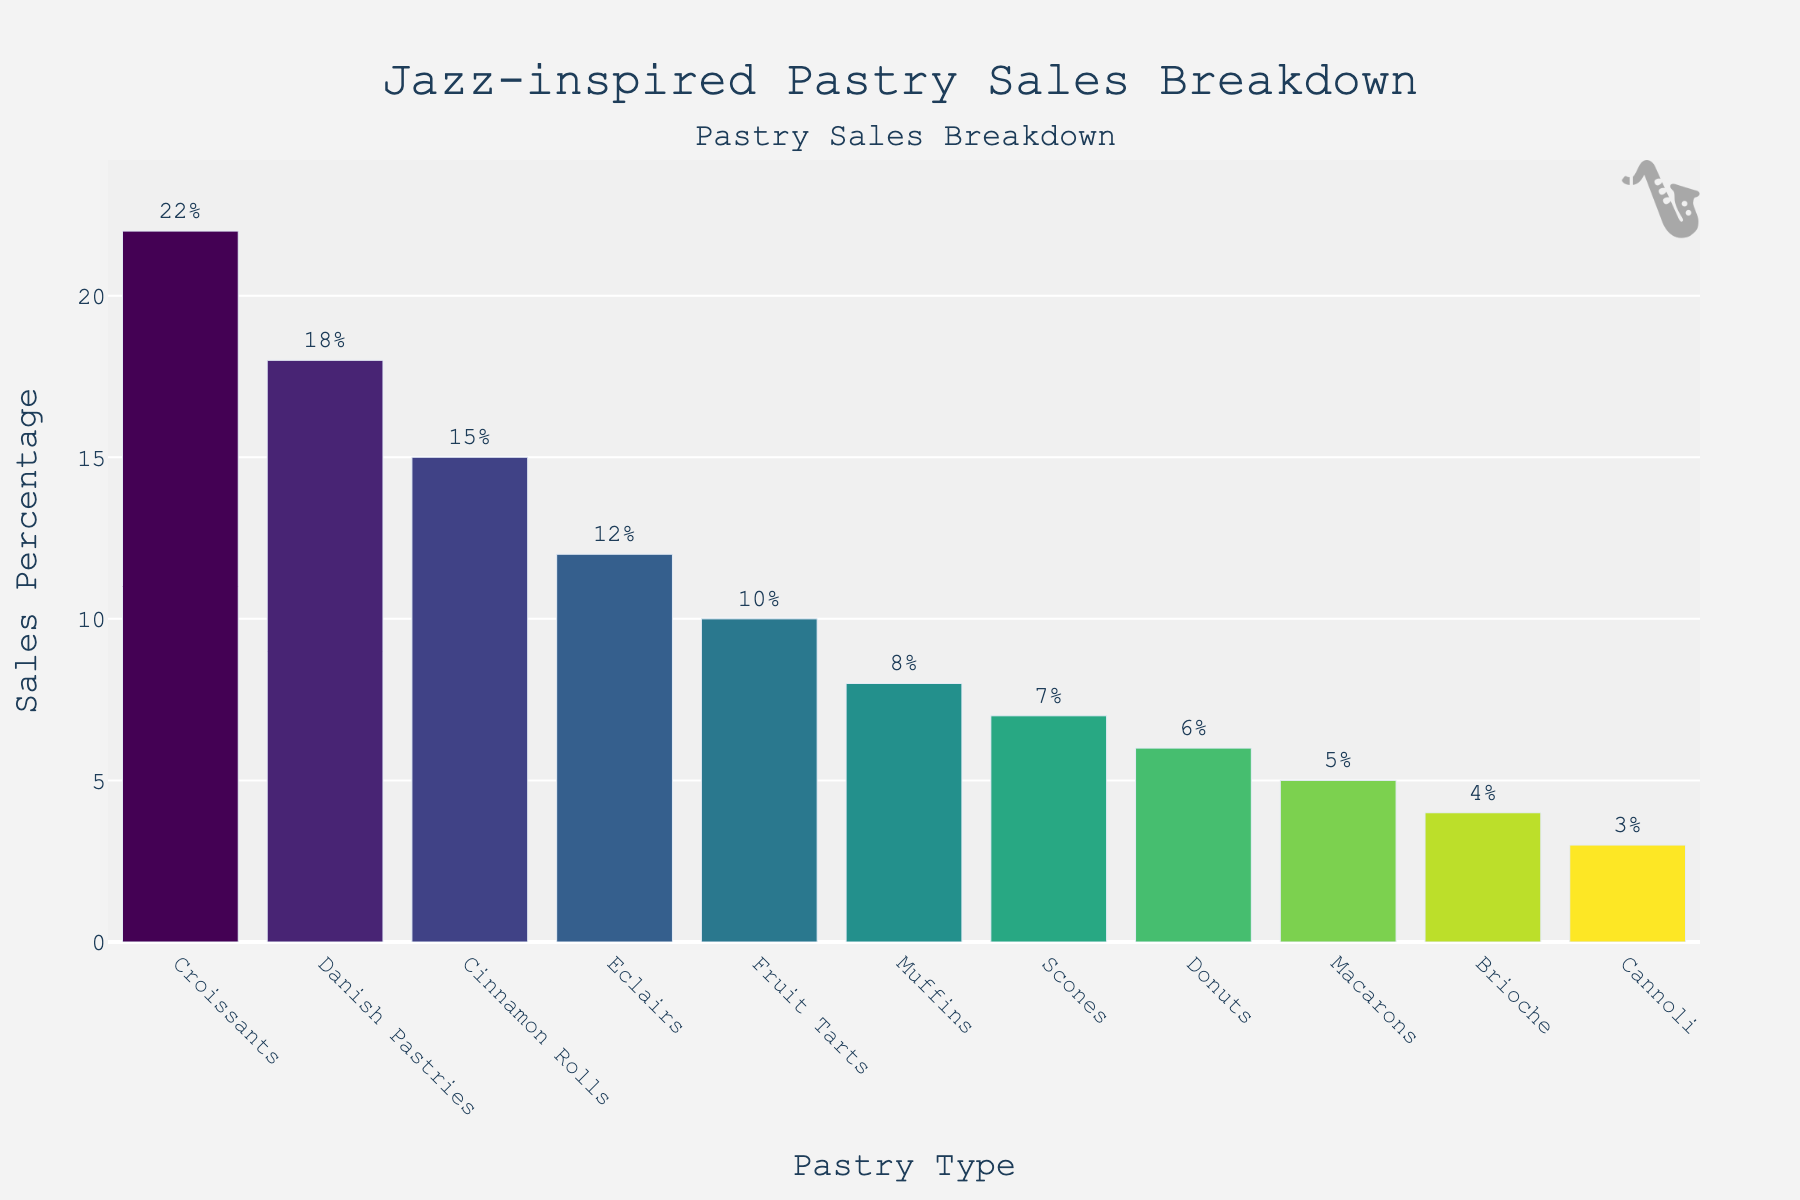Which pastry type has the highest sales percentage? The tallest bar in the chart represents the pastry type with the highest sales percentage. According to the values, Croissants have the highest sales percentage at 22%.
Answer: Croissants Which pastry type has the lowest sales percentage? The shortest bar in the chart represents the pastry type with the lowest sales percentage. The data indicates that Cannoli has the lowest sales percentage at 3%.
Answer: Cannoli How much greater is the sales percentage of Croissants compared to Fruit Tarts? To find this, subtract the sales percentage of Fruit Tarts (10%) from the sales percentage of Croissants (22%). The difference is 22% - 10% = 12%.
Answer: 12% What is the combined sales percentage of Cinnamon Rolls and Eclairs? Add the sales percentages of Cinnamon Rolls (15%) and Eclairs (12%) together. The total is 15% + 12% = 27%.
Answer: 27% Which pastries have a sales percentage greater than 10%? The pastries with bars higher than the 10% mark are Croissants, Danish Pastries, Cinnamon Rolls, and Eclairs.
Answer: Croissants, Danish Pastries, Cinnamon Rolls, Eclairs Which pastry type ranks fifth in terms of sales percentage? By looking at the sorted data in descending order, the fifth highest sales percentage is Fruit Tarts with 10%.
Answer: Fruit Tarts What is the average sales percentage of the top three pastry types? Sum the sales percentages of the top three pastry types (Croissants 22%, Danish Pastries 18%, Cinnamon Rolls 15%) and divide by 3 to find the average: (22% + 18% + 15%) / 3 = 55% / 3 = 18.33%.
Answer: 18.33% How do the sales percentages of Muffins and Scones compare? Muffins have a sales percentage of 8%, while Scones have 7%. By comparing these values, Muffins have a slightly higher sales percentage than Scones.
Answer: Muffins What is the total sales percentage of all the pastries combined? Sum all the sales percentages from the data (22% + 18% + 15% + 12% + 10% + 8% + 7% + 6% + 5% + 4% + 3%). The total is 110%.
Answer: 110% Which two pastry types are most similar in sales percentage? By examining the chart, Muffins (8%) and Scones (7%) have the most closely matched sales percentages, with only a 1% difference between them.
Answer: Muffins and Scones 